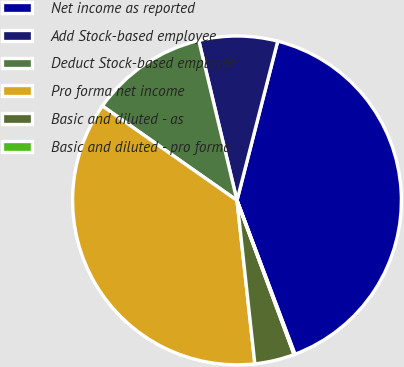Convert chart to OTSL. <chart><loc_0><loc_0><loc_500><loc_500><pie_chart><fcel>Net income as reported<fcel>Add Stock-based employee<fcel>Deduct Stock-based employee<fcel>Pro forma net income<fcel>Basic and diluted - as<fcel>Basic and diluted - pro forma<nl><fcel>40.28%<fcel>7.72%<fcel>11.53%<fcel>36.47%<fcel>3.91%<fcel>0.09%<nl></chart> 